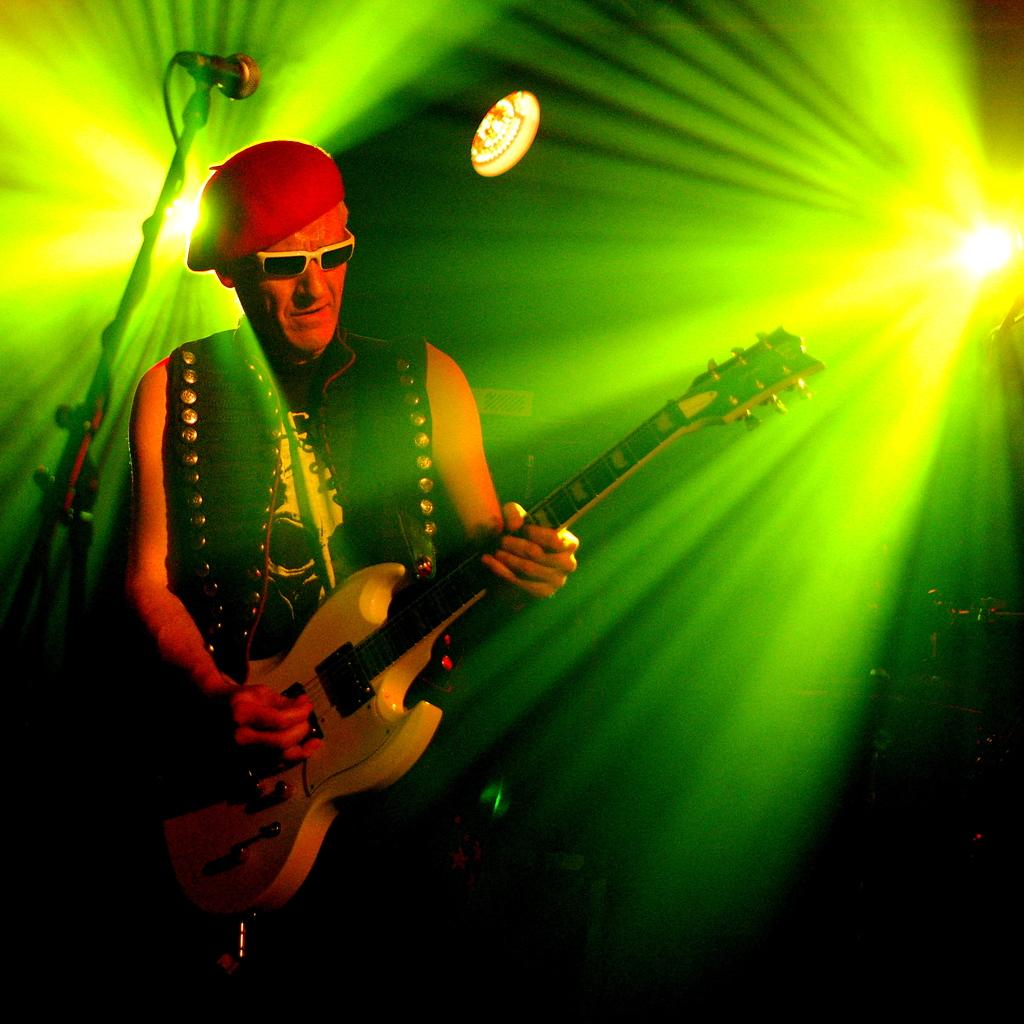What is the man in the image doing? The man is playing a guitar in the image. What object is present that is typically used for amplifying sound? There is a microphone in the image. What is the microphone attached to in the image? There is a microphone stand in the image. What can be seen in the background of the image? There are focus lights in the background of the image. What type of orange is being used as a prop in the image? There is no orange present in the image. Can you solve the riddle that is being presented by the man in the image? There is no riddle being presented by the man in the image. 